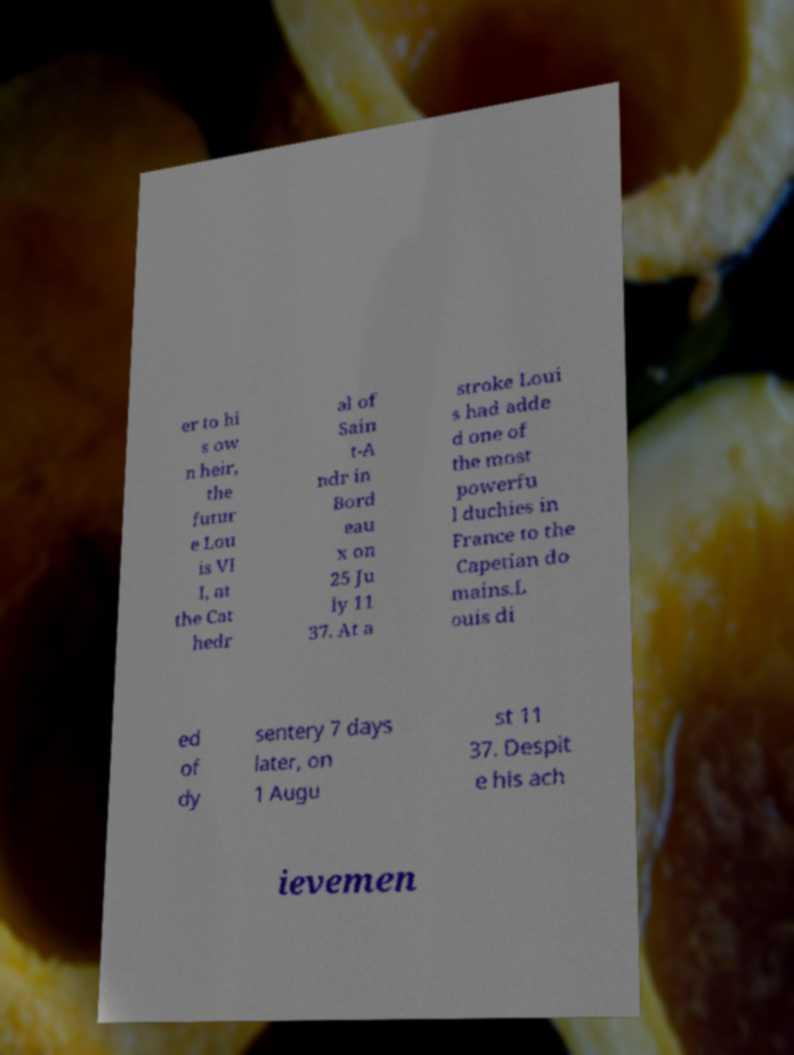I need the written content from this picture converted into text. Can you do that? er to hi s ow n heir, the futur e Lou is VI I, at the Cat hedr al of Sain t-A ndr in Bord eau x on 25 Ju ly 11 37. At a stroke Loui s had adde d one of the most powerfu l duchies in France to the Capetian do mains.L ouis di ed of dy sentery 7 days later, on 1 Augu st 11 37. Despit e his ach ievemen 